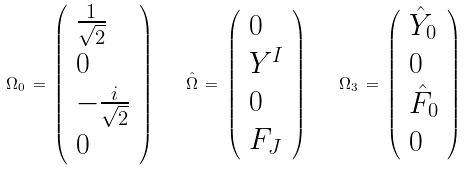Convert formula to latex. <formula><loc_0><loc_0><loc_500><loc_500>\Omega _ { 0 } \, = \, \left ( \begin{array} { l } { { { \frac { 1 } { \sqrt { 2 } } } } } \\ { 0 } \\ { { - { \frac { i } { \sqrt { 2 } } } } } \\ { 0 } \end{array} \right ) \quad { \hat { \Omega } } \, = \, \left ( \begin{array} { l } { 0 } \\ { { Y ^ { I } } } \\ { 0 } \\ { { F _ { J } } } \end{array} \right ) \quad \Omega _ { 3 } \, = \, \left ( \begin{array} { l } { { { \hat { Y } } _ { 0 } } } \\ { 0 } \\ { { { \hat { F } } _ { 0 } } } \\ { 0 } \end{array} \right )</formula> 